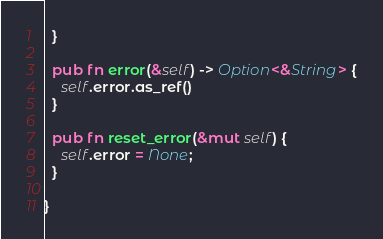<code> <loc_0><loc_0><loc_500><loc_500><_Rust_>  }

  pub fn error(&self) -> Option<&String> {
    self.error.as_ref()
  }

  pub fn reset_error(&mut self) {
    self.error = None;
  }

}



</code> 